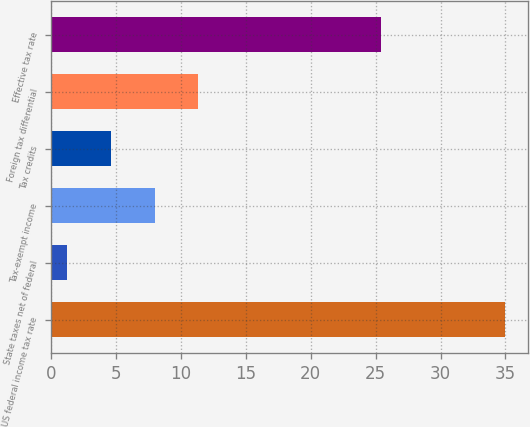Convert chart. <chart><loc_0><loc_0><loc_500><loc_500><bar_chart><fcel>US federal income tax rate<fcel>State taxes net of federal<fcel>Tax-exempt income<fcel>Tax credits<fcel>Foreign tax differential<fcel>Effective tax rate<nl><fcel>35<fcel>1.2<fcel>7.96<fcel>4.58<fcel>11.34<fcel>25.4<nl></chart> 